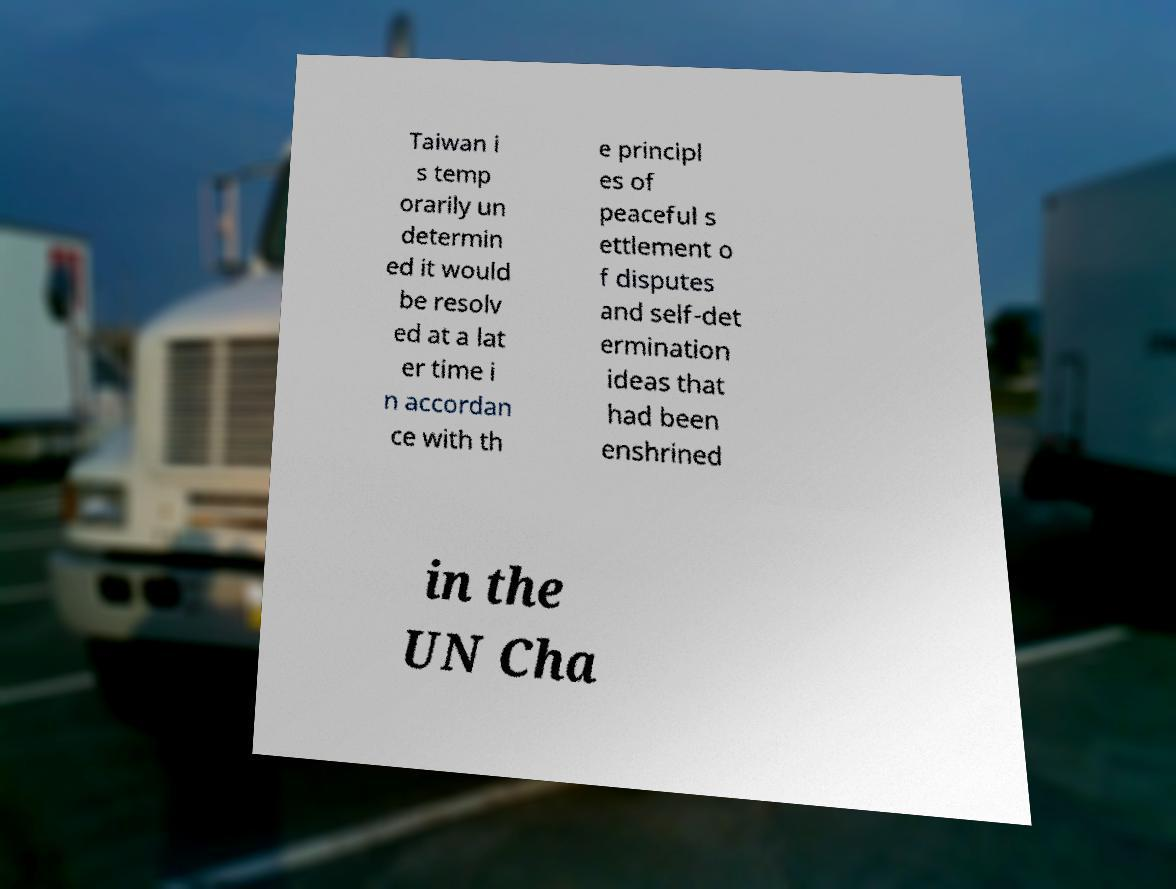For documentation purposes, I need the text within this image transcribed. Could you provide that? Taiwan i s temp orarily un determin ed it would be resolv ed at a lat er time i n accordan ce with th e principl es of peaceful s ettlement o f disputes and self-det ermination ideas that had been enshrined in the UN Cha 